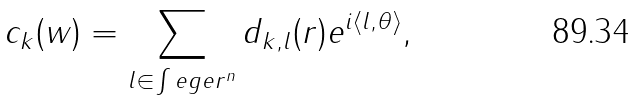<formula> <loc_0><loc_0><loc_500><loc_500>c _ { k } ( w ) = \sum _ { l \in \int e g e r ^ { n } } d _ { k , l } ( r ) e ^ { i \langle l , \theta \rangle } ,</formula> 